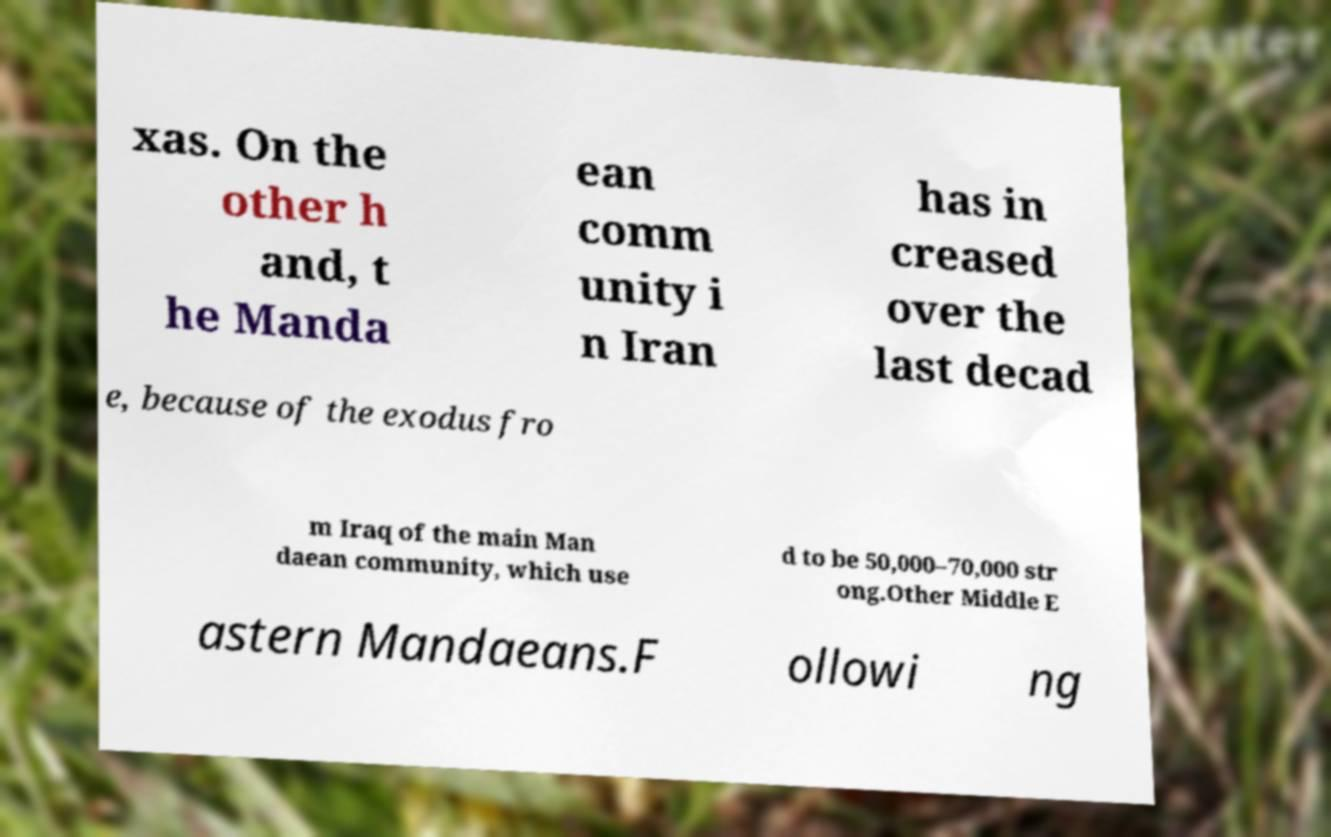For documentation purposes, I need the text within this image transcribed. Could you provide that? xas. On the other h and, t he Manda ean comm unity i n Iran has in creased over the last decad e, because of the exodus fro m Iraq of the main Man daean community, which use d to be 50,000–70,000 str ong.Other Middle E astern Mandaeans.F ollowi ng 